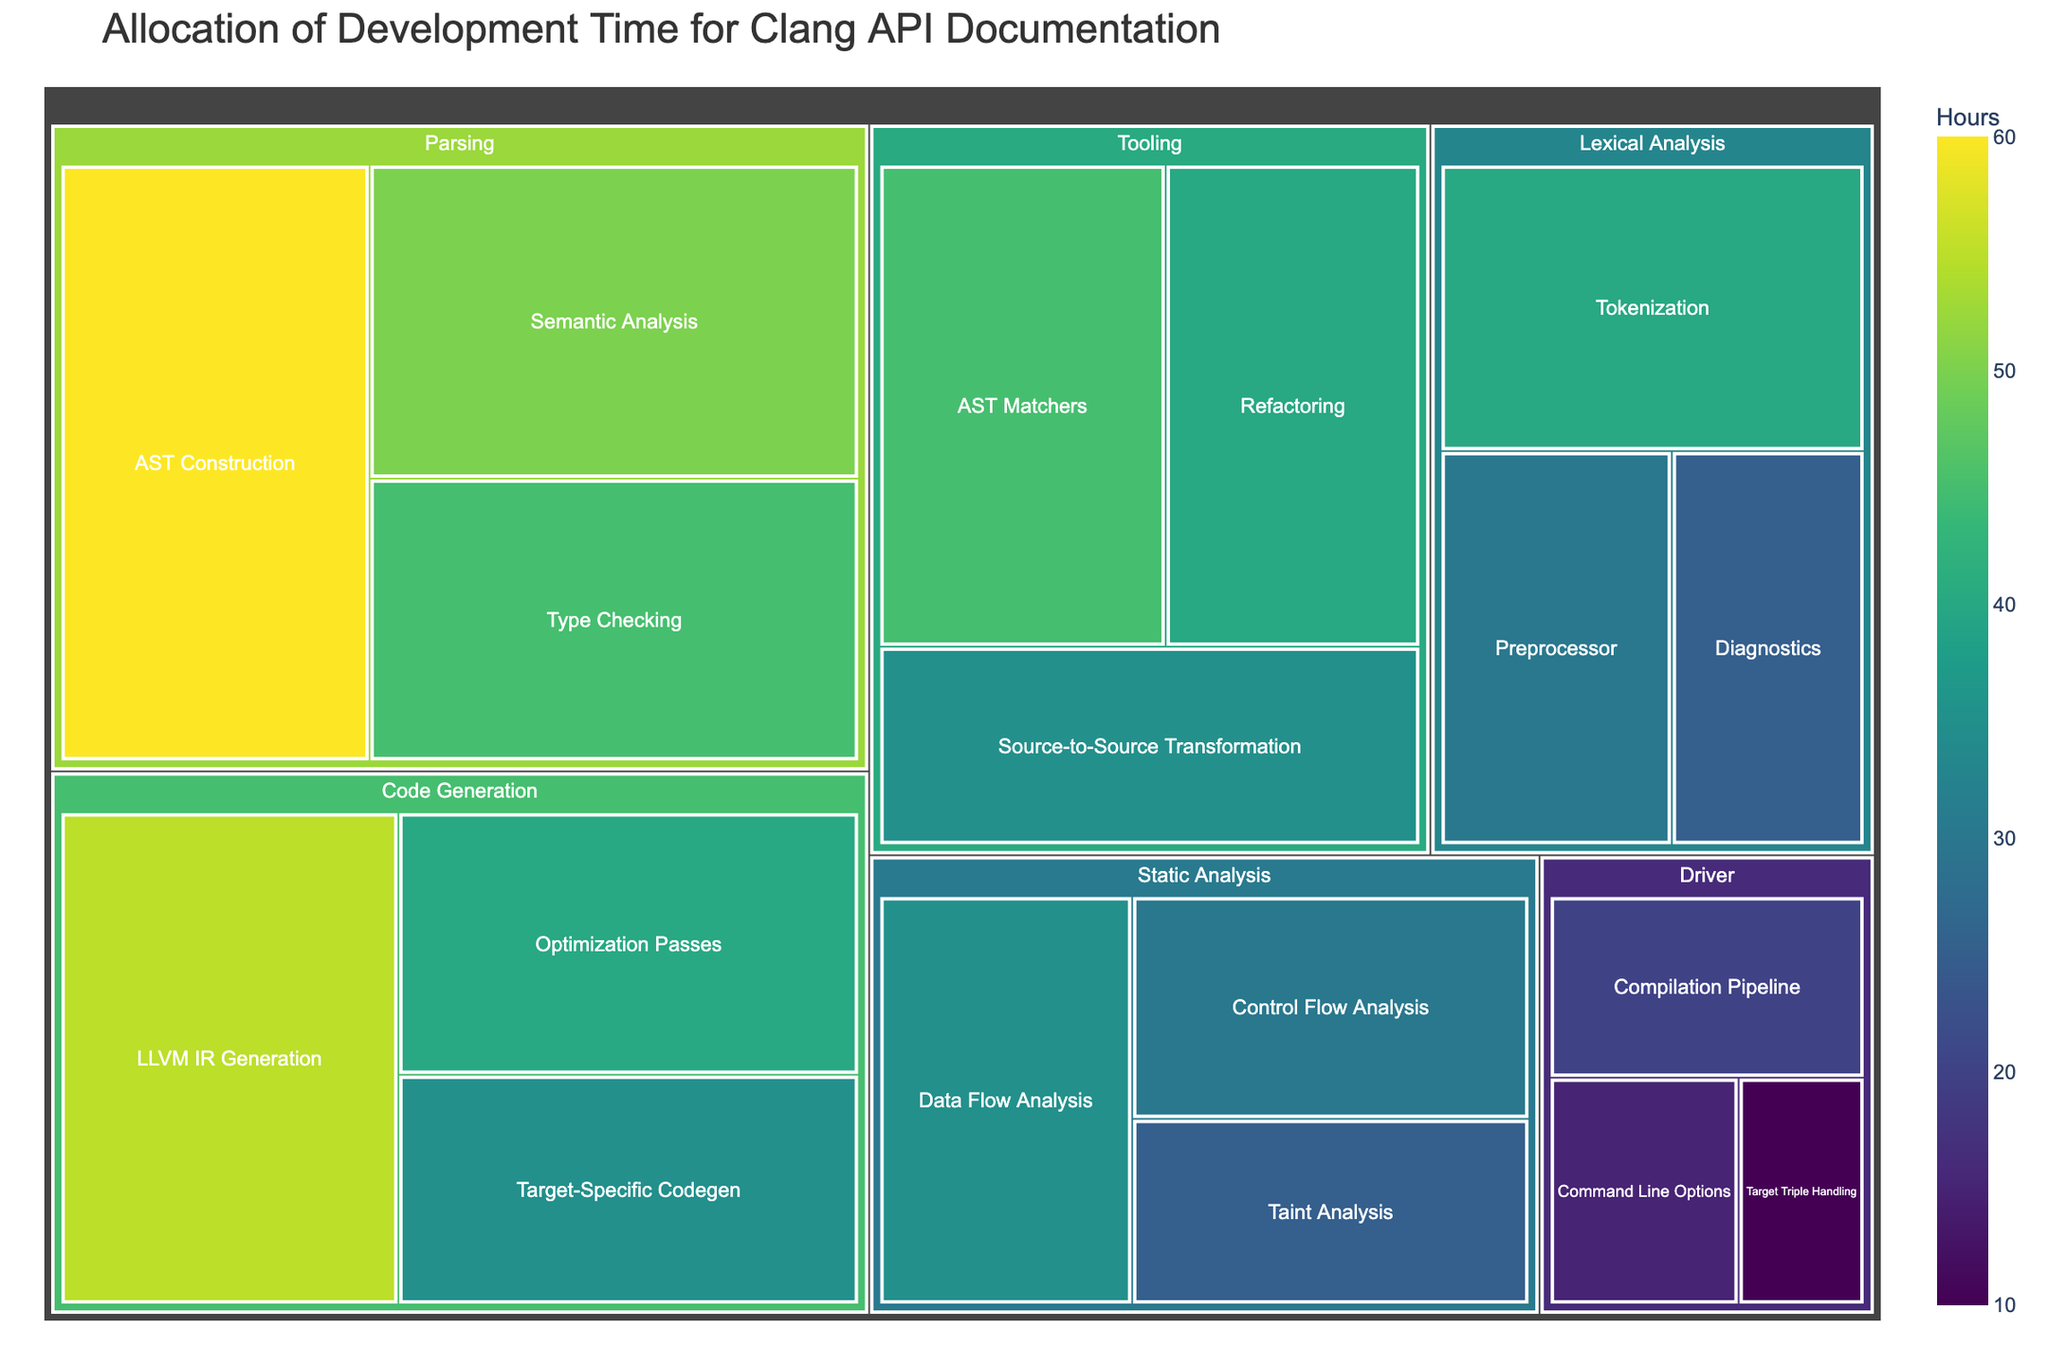What is the title of the treemap? The title of the treemap is displayed at the top of the figure in large, bold text. It provides an overview of what the treemap represents.
Answer: Allocation of Development Time for Clang API Documentation Which submodule under "Parsing" has the highest allocated hours? To determine this, we need to look at the submodules under the "Parsing" module and compare their allocated hours. The submodule with the highest value is the one with the largest area in the treemap under Parsing.
Answer: AST Construction How many hours are allocated to "Target Triple Handling" in the "Driver" module? Find the "Driver" module and then locate the "Target Triple Handling" submodule. The exact hours are displayed within or near the rectangle representing this submodule.
Answer: 10 What is the total number of hours allocated to the "Static Analysis" module? Sum up the hours of all the submodules under "Static Analysis". The submodules and their hours are: Control Flow Analysis (30), Data Flow Analysis (35), and Taint Analysis (25). The total is 30 + 35 + 25.
Answer: 90 Compare the allocated hours between "Tokenization" and "LLVM IR Generation". Which submodule has more hours? Locate "Tokenization" under "Lexical Analysis" and "LLVM IR Generation" under "Code Generation". Compare their values to determine which one is higher.
Answer: LLVM IR Generation What is the average number of hours allocated per submodule within the "Tooling" module? Calculate the average by adding the hours of all submodules under "Tooling" and then dividing by the number of submodules. The hours are 45, 40, and 35. The total is 45 + 40 + 35. There are 3 submodules. So, the average is (45+40+35)/3.
Answer: 40 Are there more hours allocated to "Refactoring" or "Preprocessor"? Locate the submodules "Refactoring" under "Tooling" and "Preprocessor" under "Lexical Analysis" and compare their allocated hours.
Answer: Refactoring What is the difference in allocated hours between AST Construction and Type Checking under the "Parsing" module? Find the hours allocated to "AST Construction" (60) and "Type Checking" (45). Subtract the smaller number from the larger number to find the difference.
Answer: 15 What is the total number of hours allocated to the "Driver" module? Add the hours of all submodules under the "Driver" module. The submodules and their hours are: Compilation Pipeline (20), Command Line Options (15), and Target Triple Handling (10). The total is 20 + 15 + 10.
Answer: 45 Which module has the least number of total allocated hours? Sum the hours of all submodules for each module and compare the totals. The module with the smallest sum is the one with the least allocated hours.
Answer: Driver 